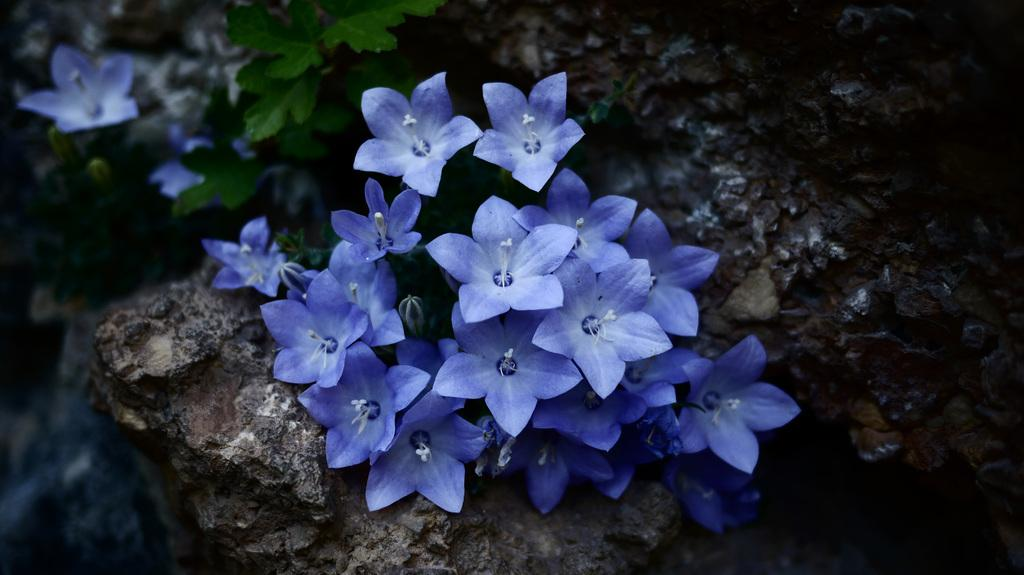What type of plant is visible in the image? There is a plant with buds and flowers in the image. What other object can be seen in the image? There is a rock in the image. Can you describe the background of the image? The background of the image is blurred. How many rabbits are sitting on the rock in the image? There are no rabbits present in the image; it only features a plant and a rock. What sound does the whistle make in the image? There is no whistle present in the image. 